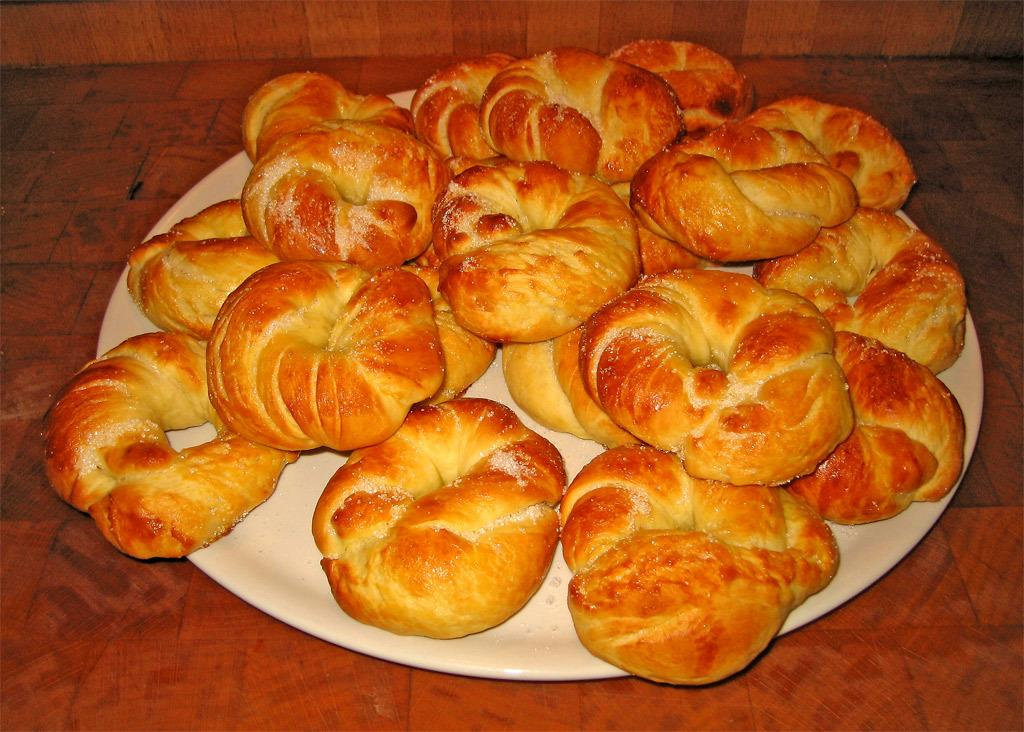What is the color of the plate in the image? The plate in the image is white. What is on the plate? The plate contains food items or eatables. On what surface is the plate placed? The plate is placed on a brown table. What type of pest can be seen crawling on the food items on the plate? There is no pest visible on the food items on the plate in the image. 